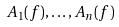Convert formula to latex. <formula><loc_0><loc_0><loc_500><loc_500>A _ { 1 } ( f ) , \dots , A _ { n } ( f )</formula> 